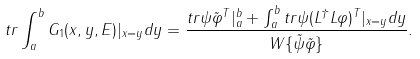Convert formula to latex. <formula><loc_0><loc_0><loc_500><loc_500>t r \int ^ { b } _ { a } G _ { 1 } ( x , y , E ) | _ { x = y } d y = \frac { t r \psi \tilde { \varphi } ^ { T } | ^ { b } _ { a } + \int ^ { b } _ { a } t r \psi ( L ^ { \dagger } L \varphi ) ^ { T } | _ { x = y } d y } { W \{ \tilde { \psi } \tilde { \varphi } \} } .</formula> 